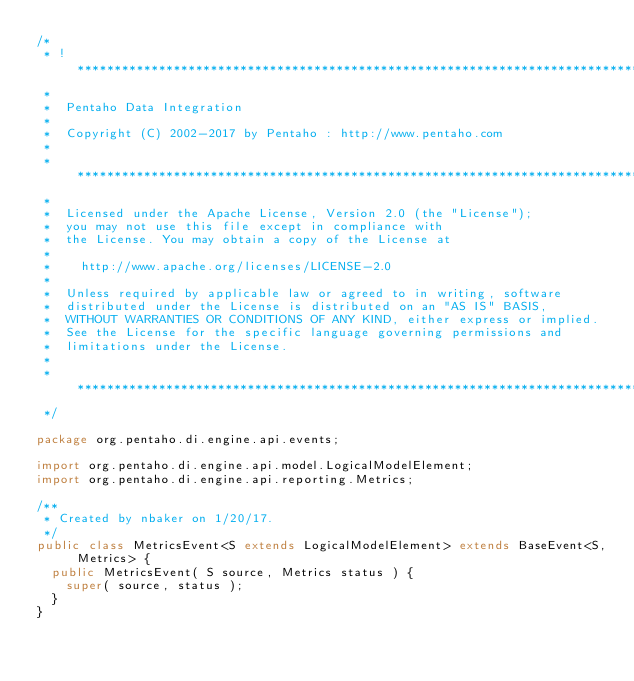Convert code to text. <code><loc_0><loc_0><loc_500><loc_500><_Java_>/*
 * ! ******************************************************************************
 *
 *  Pentaho Data Integration
 *
 *  Copyright (C) 2002-2017 by Pentaho : http://www.pentaho.com
 *
 * ******************************************************************************
 *
 *  Licensed under the Apache License, Version 2.0 (the "License");
 *  you may not use this file except in compliance with
 *  the License. You may obtain a copy of the License at
 *
 *    http://www.apache.org/licenses/LICENSE-2.0
 *
 *  Unless required by applicable law or agreed to in writing, software
 *  distributed under the License is distributed on an "AS IS" BASIS,
 *  WITHOUT WARRANTIES OR CONDITIONS OF ANY KIND, either express or implied.
 *  See the License for the specific language governing permissions and
 *  limitations under the License.
 *
 * *****************************************************************************
 */

package org.pentaho.di.engine.api.events;

import org.pentaho.di.engine.api.model.LogicalModelElement;
import org.pentaho.di.engine.api.reporting.Metrics;

/**
 * Created by nbaker on 1/20/17.
 */
public class MetricsEvent<S extends LogicalModelElement> extends BaseEvent<S, Metrics> {
  public MetricsEvent( S source, Metrics status ) {
    super( source, status );
  }
}
</code> 